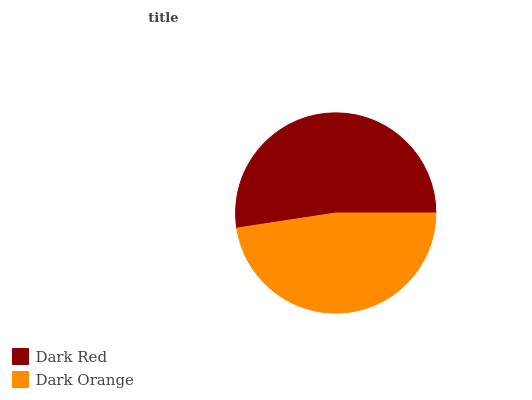Is Dark Orange the minimum?
Answer yes or no. Yes. Is Dark Red the maximum?
Answer yes or no. Yes. Is Dark Orange the maximum?
Answer yes or no. No. Is Dark Red greater than Dark Orange?
Answer yes or no. Yes. Is Dark Orange less than Dark Red?
Answer yes or no. Yes. Is Dark Orange greater than Dark Red?
Answer yes or no. No. Is Dark Red less than Dark Orange?
Answer yes or no. No. Is Dark Red the high median?
Answer yes or no. Yes. Is Dark Orange the low median?
Answer yes or no. Yes. Is Dark Orange the high median?
Answer yes or no. No. Is Dark Red the low median?
Answer yes or no. No. 